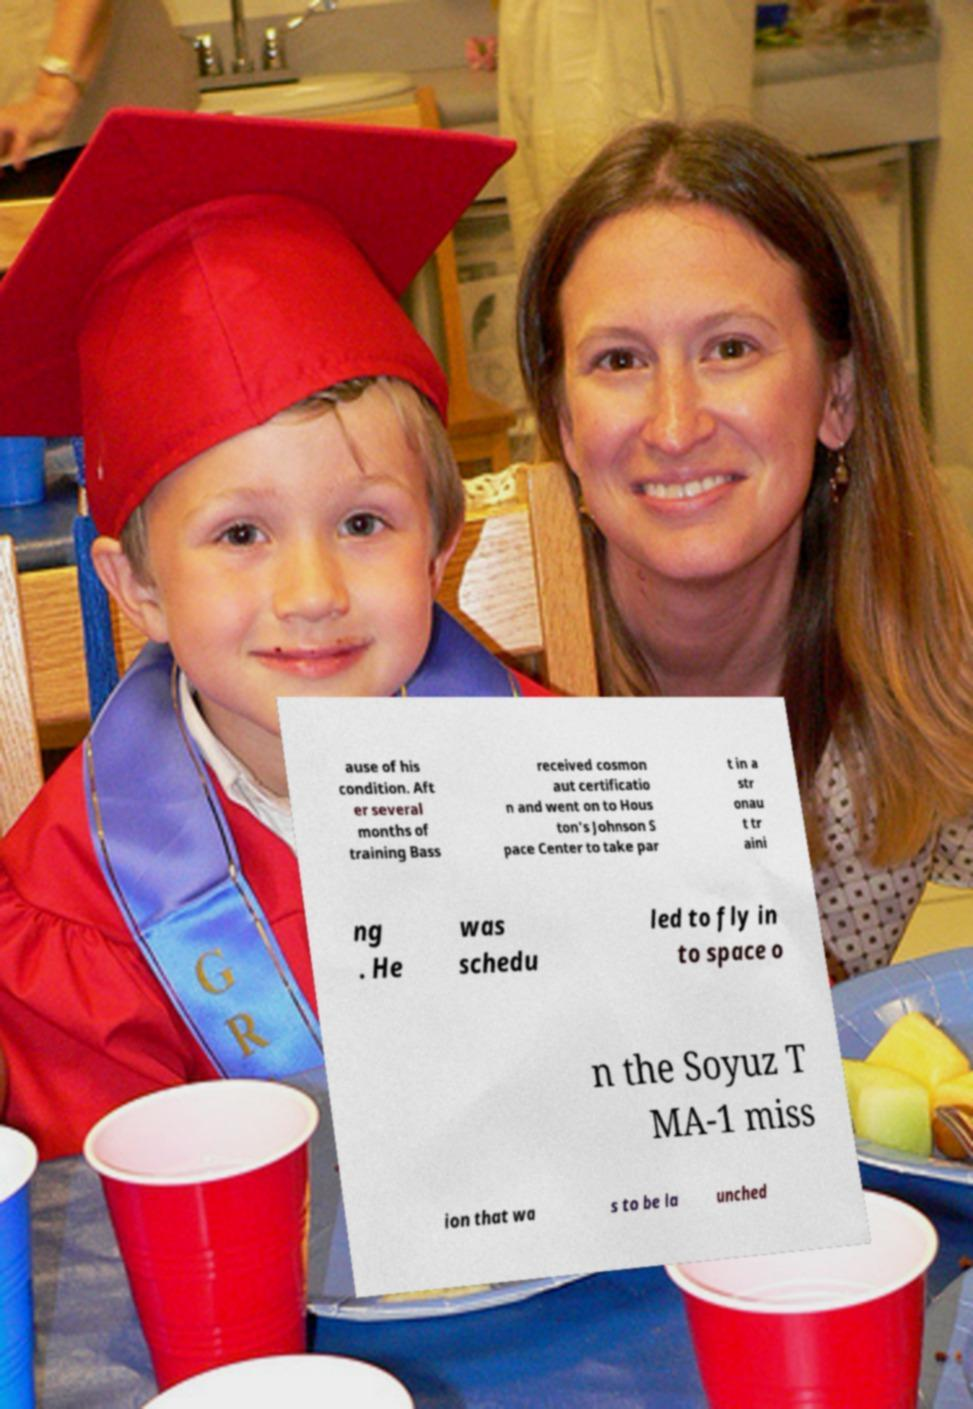Could you assist in decoding the text presented in this image and type it out clearly? ause of his condition. Aft er several months of training Bass received cosmon aut certificatio n and went on to Hous ton's Johnson S pace Center to take par t in a str onau t tr aini ng . He was schedu led to fly in to space o n the Soyuz T MA-1 miss ion that wa s to be la unched 